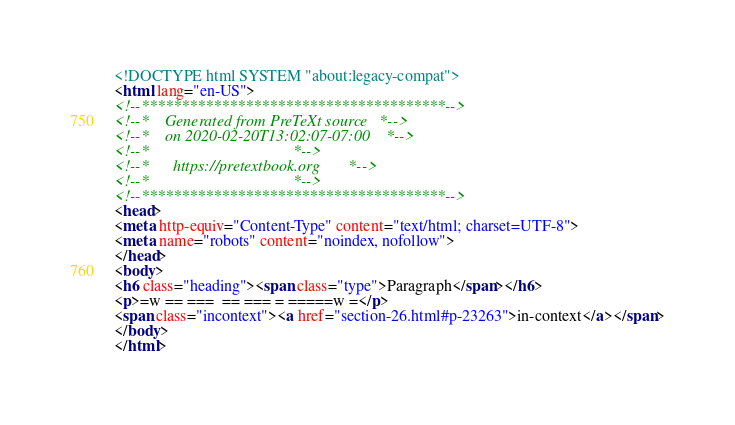<code> <loc_0><loc_0><loc_500><loc_500><_HTML_><!DOCTYPE html SYSTEM "about:legacy-compat">
<html lang="en-US">
<!--**************************************-->
<!--*    Generated from PreTeXt source   *-->
<!--*    on 2020-02-20T13:02:07-07:00    *-->
<!--*                                    *-->
<!--*      https://pretextbook.org       *-->
<!--*                                    *-->
<!--**************************************-->
<head>
<meta http-equiv="Content-Type" content="text/html; charset=UTF-8">
<meta name="robots" content="noindex, nofollow">
</head>
<body>
<h6 class="heading"><span class="type">Paragraph</span></h6>
<p>=w == ===  == === = =====w =</p>
<span class="incontext"><a href="section-26.html#p-23263">in-context</a></span>
</body>
</html>
</code> 